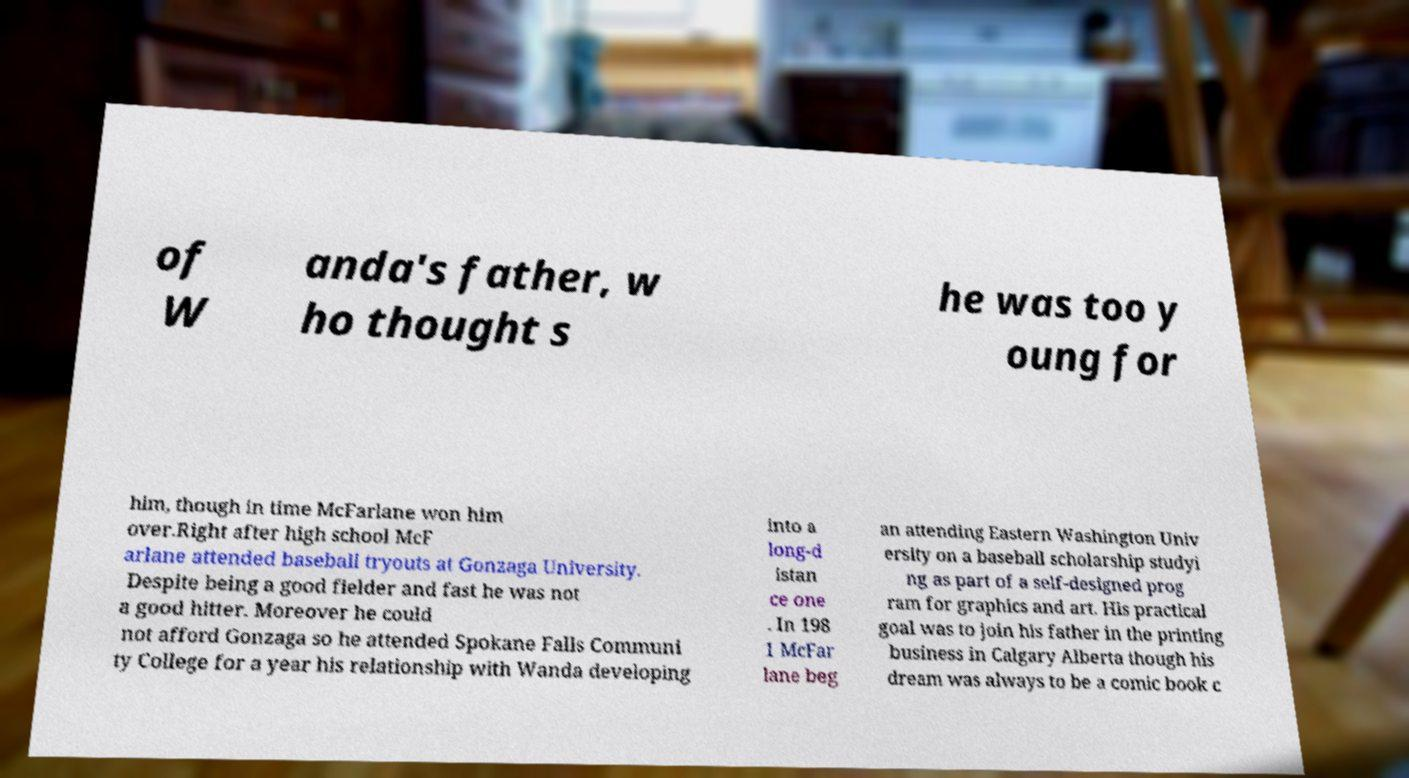Can you read and provide the text displayed in the image?This photo seems to have some interesting text. Can you extract and type it out for me? of W anda's father, w ho thought s he was too y oung for him, though in time McFarlane won him over.Right after high school McF arlane attended baseball tryouts at Gonzaga University. Despite being a good fielder and fast he was not a good hitter. Moreover he could not afford Gonzaga so he attended Spokane Falls Communi ty College for a year his relationship with Wanda developing into a long-d istan ce one . In 198 1 McFar lane beg an attending Eastern Washington Univ ersity on a baseball scholarship studyi ng as part of a self-designed prog ram for graphics and art. His practical goal was to join his father in the printing business in Calgary Alberta though his dream was always to be a comic book c 